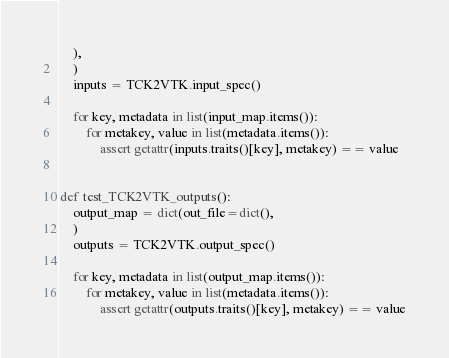Convert code to text. <code><loc_0><loc_0><loc_500><loc_500><_Python_>    ),
    )
    inputs = TCK2VTK.input_spec()

    for key, metadata in list(input_map.items()):
        for metakey, value in list(metadata.items()):
            assert getattr(inputs.traits()[key], metakey) == value


def test_TCK2VTK_outputs():
    output_map = dict(out_file=dict(),
    )
    outputs = TCK2VTK.output_spec()

    for key, metadata in list(output_map.items()):
        for metakey, value in list(metadata.items()):
            assert getattr(outputs.traits()[key], metakey) == value
</code> 